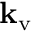Convert formula to latex. <formula><loc_0><loc_0><loc_500><loc_500>k _ { v }</formula> 